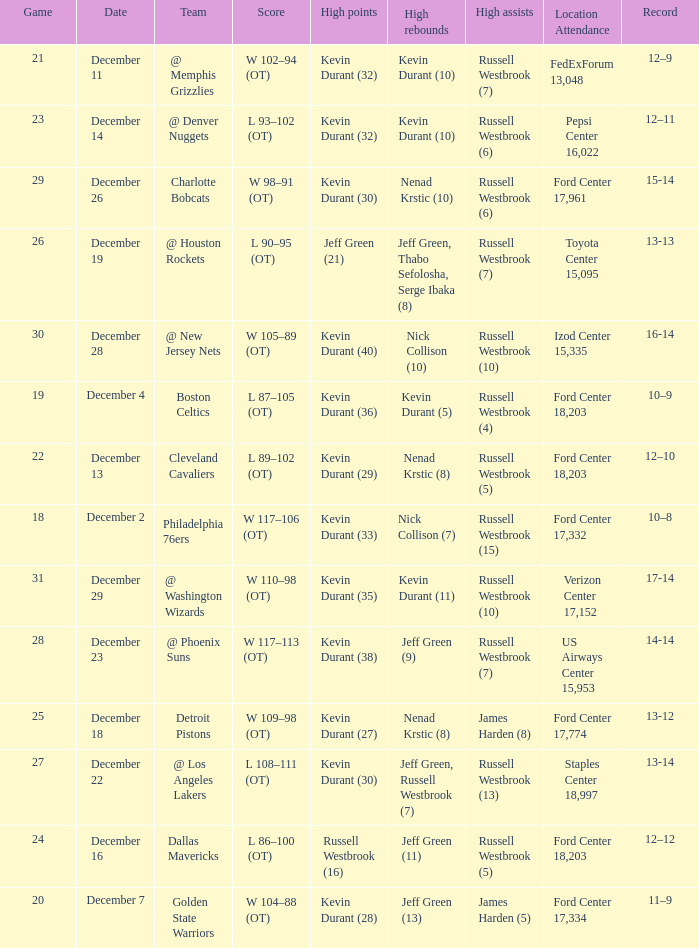Who has high points when verizon center 17,152 is location attendance? Kevin Durant (35). Could you help me parse every detail presented in this table? {'header': ['Game', 'Date', 'Team', 'Score', 'High points', 'High rebounds', 'High assists', 'Location Attendance', 'Record'], 'rows': [['21', 'December 11', '@ Memphis Grizzlies', 'W 102–94 (OT)', 'Kevin Durant (32)', 'Kevin Durant (10)', 'Russell Westbrook (7)', 'FedExForum 13,048', '12–9'], ['23', 'December 14', '@ Denver Nuggets', 'L 93–102 (OT)', 'Kevin Durant (32)', 'Kevin Durant (10)', 'Russell Westbrook (6)', 'Pepsi Center 16,022', '12–11'], ['29', 'December 26', 'Charlotte Bobcats', 'W 98–91 (OT)', 'Kevin Durant (30)', 'Nenad Krstic (10)', 'Russell Westbrook (6)', 'Ford Center 17,961', '15-14'], ['26', 'December 19', '@ Houston Rockets', 'L 90–95 (OT)', 'Jeff Green (21)', 'Jeff Green, Thabo Sefolosha, Serge Ibaka (8)', 'Russell Westbrook (7)', 'Toyota Center 15,095', '13-13'], ['30', 'December 28', '@ New Jersey Nets', 'W 105–89 (OT)', 'Kevin Durant (40)', 'Nick Collison (10)', 'Russell Westbrook (10)', 'Izod Center 15,335', '16-14'], ['19', 'December 4', 'Boston Celtics', 'L 87–105 (OT)', 'Kevin Durant (36)', 'Kevin Durant (5)', 'Russell Westbrook (4)', 'Ford Center 18,203', '10–9'], ['22', 'December 13', 'Cleveland Cavaliers', 'L 89–102 (OT)', 'Kevin Durant (29)', 'Nenad Krstic (8)', 'Russell Westbrook (5)', 'Ford Center 18,203', '12–10'], ['18', 'December 2', 'Philadelphia 76ers', 'W 117–106 (OT)', 'Kevin Durant (33)', 'Nick Collison (7)', 'Russell Westbrook (15)', 'Ford Center 17,332', '10–8'], ['31', 'December 29', '@ Washington Wizards', 'W 110–98 (OT)', 'Kevin Durant (35)', 'Kevin Durant (11)', 'Russell Westbrook (10)', 'Verizon Center 17,152', '17-14'], ['28', 'December 23', '@ Phoenix Suns', 'W 117–113 (OT)', 'Kevin Durant (38)', 'Jeff Green (9)', 'Russell Westbrook (7)', 'US Airways Center 15,953', '14-14'], ['25', 'December 18', 'Detroit Pistons', 'W 109–98 (OT)', 'Kevin Durant (27)', 'Nenad Krstic (8)', 'James Harden (8)', 'Ford Center 17,774', '13-12'], ['27', 'December 22', '@ Los Angeles Lakers', 'L 108–111 (OT)', 'Kevin Durant (30)', 'Jeff Green, Russell Westbrook (7)', 'Russell Westbrook (13)', 'Staples Center 18,997', '13-14'], ['24', 'December 16', 'Dallas Mavericks', 'L 86–100 (OT)', 'Russell Westbrook (16)', 'Jeff Green (11)', 'Russell Westbrook (5)', 'Ford Center 18,203', '12–12'], ['20', 'December 7', 'Golden State Warriors', 'W 104–88 (OT)', 'Kevin Durant (28)', 'Jeff Green (13)', 'James Harden (5)', 'Ford Center 17,334', '11–9']]} 